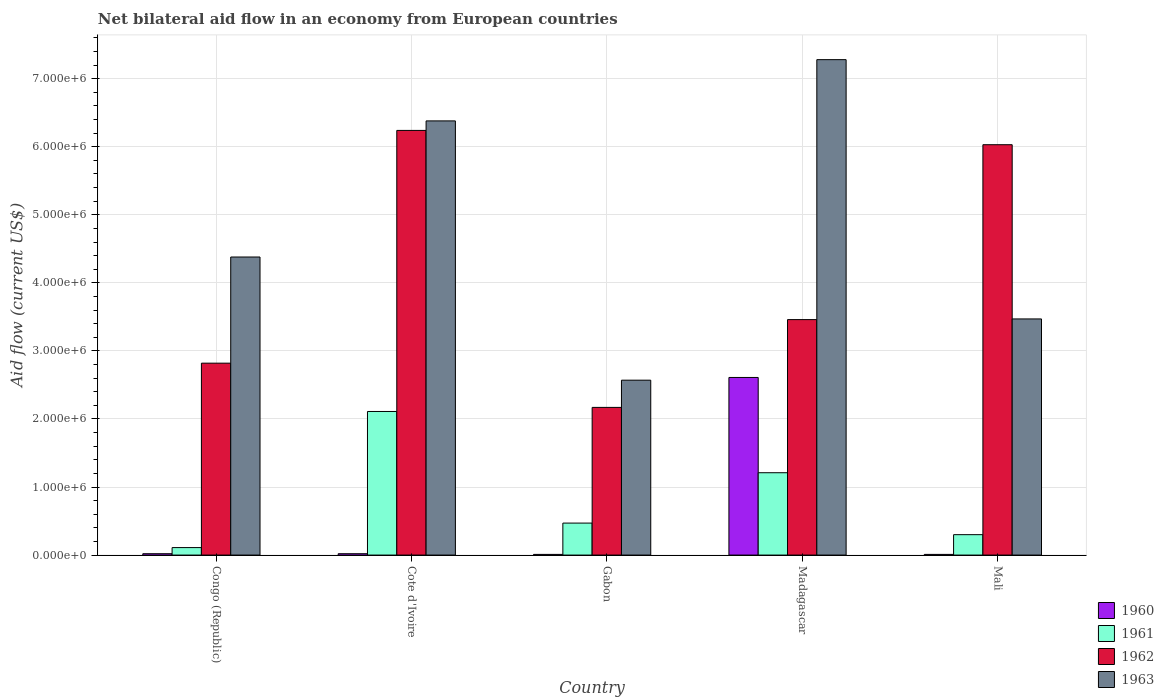How many different coloured bars are there?
Your response must be concise. 4. Are the number of bars per tick equal to the number of legend labels?
Offer a terse response. Yes. How many bars are there on the 4th tick from the right?
Your answer should be compact. 4. What is the label of the 1st group of bars from the left?
Your response must be concise. Congo (Republic). In how many cases, is the number of bars for a given country not equal to the number of legend labels?
Provide a short and direct response. 0. What is the net bilateral aid flow in 1960 in Congo (Republic)?
Offer a very short reply. 2.00e+04. Across all countries, what is the maximum net bilateral aid flow in 1960?
Your response must be concise. 2.61e+06. Across all countries, what is the minimum net bilateral aid flow in 1963?
Make the answer very short. 2.57e+06. In which country was the net bilateral aid flow in 1960 maximum?
Offer a terse response. Madagascar. In which country was the net bilateral aid flow in 1962 minimum?
Give a very brief answer. Gabon. What is the total net bilateral aid flow in 1962 in the graph?
Provide a short and direct response. 2.07e+07. What is the difference between the net bilateral aid flow in 1963 in Cote d'Ivoire and that in Madagascar?
Your response must be concise. -9.00e+05. What is the difference between the net bilateral aid flow in 1960 in Gabon and the net bilateral aid flow in 1962 in Mali?
Your response must be concise. -6.02e+06. What is the average net bilateral aid flow in 1962 per country?
Offer a very short reply. 4.14e+06. What is the difference between the net bilateral aid flow of/in 1960 and net bilateral aid flow of/in 1963 in Cote d'Ivoire?
Provide a succinct answer. -6.36e+06. What is the ratio of the net bilateral aid flow in 1960 in Congo (Republic) to that in Madagascar?
Your answer should be compact. 0.01. Is the net bilateral aid flow in 1963 in Congo (Republic) less than that in Madagascar?
Keep it short and to the point. Yes. What is the difference between the highest and the second highest net bilateral aid flow in 1960?
Offer a very short reply. 2.59e+06. What is the difference between the highest and the lowest net bilateral aid flow in 1960?
Give a very brief answer. 2.60e+06. Is the sum of the net bilateral aid flow in 1960 in Cote d'Ivoire and Madagascar greater than the maximum net bilateral aid flow in 1963 across all countries?
Keep it short and to the point. No. Is it the case that in every country, the sum of the net bilateral aid flow in 1961 and net bilateral aid flow in 1963 is greater than the sum of net bilateral aid flow in 1960 and net bilateral aid flow in 1962?
Offer a very short reply. No. How many bars are there?
Offer a very short reply. 20. What is the difference between two consecutive major ticks on the Y-axis?
Keep it short and to the point. 1.00e+06. Are the values on the major ticks of Y-axis written in scientific E-notation?
Offer a very short reply. Yes. Does the graph contain any zero values?
Your answer should be compact. No. Where does the legend appear in the graph?
Offer a terse response. Bottom right. How are the legend labels stacked?
Provide a short and direct response. Vertical. What is the title of the graph?
Your response must be concise. Net bilateral aid flow in an economy from European countries. What is the label or title of the X-axis?
Provide a short and direct response. Country. What is the Aid flow (current US$) in 1960 in Congo (Republic)?
Your answer should be compact. 2.00e+04. What is the Aid flow (current US$) of 1961 in Congo (Republic)?
Your response must be concise. 1.10e+05. What is the Aid flow (current US$) of 1962 in Congo (Republic)?
Your answer should be very brief. 2.82e+06. What is the Aid flow (current US$) of 1963 in Congo (Republic)?
Provide a succinct answer. 4.38e+06. What is the Aid flow (current US$) of 1960 in Cote d'Ivoire?
Give a very brief answer. 2.00e+04. What is the Aid flow (current US$) of 1961 in Cote d'Ivoire?
Offer a very short reply. 2.11e+06. What is the Aid flow (current US$) of 1962 in Cote d'Ivoire?
Your answer should be very brief. 6.24e+06. What is the Aid flow (current US$) in 1963 in Cote d'Ivoire?
Provide a short and direct response. 6.38e+06. What is the Aid flow (current US$) in 1960 in Gabon?
Your answer should be compact. 10000. What is the Aid flow (current US$) in 1962 in Gabon?
Provide a short and direct response. 2.17e+06. What is the Aid flow (current US$) in 1963 in Gabon?
Your answer should be compact. 2.57e+06. What is the Aid flow (current US$) of 1960 in Madagascar?
Offer a very short reply. 2.61e+06. What is the Aid flow (current US$) in 1961 in Madagascar?
Ensure brevity in your answer.  1.21e+06. What is the Aid flow (current US$) in 1962 in Madagascar?
Give a very brief answer. 3.46e+06. What is the Aid flow (current US$) in 1963 in Madagascar?
Your answer should be very brief. 7.28e+06. What is the Aid flow (current US$) in 1962 in Mali?
Give a very brief answer. 6.03e+06. What is the Aid flow (current US$) in 1963 in Mali?
Your answer should be compact. 3.47e+06. Across all countries, what is the maximum Aid flow (current US$) of 1960?
Provide a succinct answer. 2.61e+06. Across all countries, what is the maximum Aid flow (current US$) of 1961?
Your answer should be very brief. 2.11e+06. Across all countries, what is the maximum Aid flow (current US$) in 1962?
Ensure brevity in your answer.  6.24e+06. Across all countries, what is the maximum Aid flow (current US$) of 1963?
Give a very brief answer. 7.28e+06. Across all countries, what is the minimum Aid flow (current US$) in 1962?
Offer a terse response. 2.17e+06. Across all countries, what is the minimum Aid flow (current US$) of 1963?
Provide a succinct answer. 2.57e+06. What is the total Aid flow (current US$) in 1960 in the graph?
Keep it short and to the point. 2.67e+06. What is the total Aid flow (current US$) of 1961 in the graph?
Make the answer very short. 4.20e+06. What is the total Aid flow (current US$) of 1962 in the graph?
Offer a terse response. 2.07e+07. What is the total Aid flow (current US$) in 1963 in the graph?
Your answer should be compact. 2.41e+07. What is the difference between the Aid flow (current US$) in 1962 in Congo (Republic) and that in Cote d'Ivoire?
Your answer should be very brief. -3.42e+06. What is the difference between the Aid flow (current US$) in 1963 in Congo (Republic) and that in Cote d'Ivoire?
Offer a very short reply. -2.00e+06. What is the difference between the Aid flow (current US$) in 1961 in Congo (Republic) and that in Gabon?
Keep it short and to the point. -3.60e+05. What is the difference between the Aid flow (current US$) of 1962 in Congo (Republic) and that in Gabon?
Ensure brevity in your answer.  6.50e+05. What is the difference between the Aid flow (current US$) of 1963 in Congo (Republic) and that in Gabon?
Offer a terse response. 1.81e+06. What is the difference between the Aid flow (current US$) in 1960 in Congo (Republic) and that in Madagascar?
Give a very brief answer. -2.59e+06. What is the difference between the Aid flow (current US$) of 1961 in Congo (Republic) and that in Madagascar?
Your answer should be compact. -1.10e+06. What is the difference between the Aid flow (current US$) of 1962 in Congo (Republic) and that in Madagascar?
Ensure brevity in your answer.  -6.40e+05. What is the difference between the Aid flow (current US$) of 1963 in Congo (Republic) and that in Madagascar?
Keep it short and to the point. -2.90e+06. What is the difference between the Aid flow (current US$) in 1961 in Congo (Republic) and that in Mali?
Keep it short and to the point. -1.90e+05. What is the difference between the Aid flow (current US$) in 1962 in Congo (Republic) and that in Mali?
Your answer should be compact. -3.21e+06. What is the difference between the Aid flow (current US$) of 1963 in Congo (Republic) and that in Mali?
Keep it short and to the point. 9.10e+05. What is the difference between the Aid flow (current US$) of 1961 in Cote d'Ivoire and that in Gabon?
Ensure brevity in your answer.  1.64e+06. What is the difference between the Aid flow (current US$) of 1962 in Cote d'Ivoire and that in Gabon?
Your answer should be compact. 4.07e+06. What is the difference between the Aid flow (current US$) of 1963 in Cote d'Ivoire and that in Gabon?
Provide a short and direct response. 3.81e+06. What is the difference between the Aid flow (current US$) in 1960 in Cote d'Ivoire and that in Madagascar?
Your response must be concise. -2.59e+06. What is the difference between the Aid flow (current US$) in 1961 in Cote d'Ivoire and that in Madagascar?
Provide a succinct answer. 9.00e+05. What is the difference between the Aid flow (current US$) in 1962 in Cote d'Ivoire and that in Madagascar?
Ensure brevity in your answer.  2.78e+06. What is the difference between the Aid flow (current US$) in 1963 in Cote d'Ivoire and that in Madagascar?
Your answer should be compact. -9.00e+05. What is the difference between the Aid flow (current US$) in 1960 in Cote d'Ivoire and that in Mali?
Make the answer very short. 10000. What is the difference between the Aid flow (current US$) in 1961 in Cote d'Ivoire and that in Mali?
Offer a very short reply. 1.81e+06. What is the difference between the Aid flow (current US$) of 1963 in Cote d'Ivoire and that in Mali?
Keep it short and to the point. 2.91e+06. What is the difference between the Aid flow (current US$) in 1960 in Gabon and that in Madagascar?
Keep it short and to the point. -2.60e+06. What is the difference between the Aid flow (current US$) of 1961 in Gabon and that in Madagascar?
Your answer should be compact. -7.40e+05. What is the difference between the Aid flow (current US$) of 1962 in Gabon and that in Madagascar?
Offer a very short reply. -1.29e+06. What is the difference between the Aid flow (current US$) of 1963 in Gabon and that in Madagascar?
Provide a succinct answer. -4.71e+06. What is the difference between the Aid flow (current US$) of 1960 in Gabon and that in Mali?
Keep it short and to the point. 0. What is the difference between the Aid flow (current US$) of 1961 in Gabon and that in Mali?
Ensure brevity in your answer.  1.70e+05. What is the difference between the Aid flow (current US$) in 1962 in Gabon and that in Mali?
Your answer should be very brief. -3.86e+06. What is the difference between the Aid flow (current US$) in 1963 in Gabon and that in Mali?
Keep it short and to the point. -9.00e+05. What is the difference between the Aid flow (current US$) in 1960 in Madagascar and that in Mali?
Provide a short and direct response. 2.60e+06. What is the difference between the Aid flow (current US$) in 1961 in Madagascar and that in Mali?
Keep it short and to the point. 9.10e+05. What is the difference between the Aid flow (current US$) in 1962 in Madagascar and that in Mali?
Your response must be concise. -2.57e+06. What is the difference between the Aid flow (current US$) of 1963 in Madagascar and that in Mali?
Provide a short and direct response. 3.81e+06. What is the difference between the Aid flow (current US$) of 1960 in Congo (Republic) and the Aid flow (current US$) of 1961 in Cote d'Ivoire?
Offer a very short reply. -2.09e+06. What is the difference between the Aid flow (current US$) in 1960 in Congo (Republic) and the Aid flow (current US$) in 1962 in Cote d'Ivoire?
Keep it short and to the point. -6.22e+06. What is the difference between the Aid flow (current US$) of 1960 in Congo (Republic) and the Aid flow (current US$) of 1963 in Cote d'Ivoire?
Provide a succinct answer. -6.36e+06. What is the difference between the Aid flow (current US$) of 1961 in Congo (Republic) and the Aid flow (current US$) of 1962 in Cote d'Ivoire?
Provide a succinct answer. -6.13e+06. What is the difference between the Aid flow (current US$) in 1961 in Congo (Republic) and the Aid flow (current US$) in 1963 in Cote d'Ivoire?
Make the answer very short. -6.27e+06. What is the difference between the Aid flow (current US$) in 1962 in Congo (Republic) and the Aid flow (current US$) in 1963 in Cote d'Ivoire?
Keep it short and to the point. -3.56e+06. What is the difference between the Aid flow (current US$) of 1960 in Congo (Republic) and the Aid flow (current US$) of 1961 in Gabon?
Offer a very short reply. -4.50e+05. What is the difference between the Aid flow (current US$) of 1960 in Congo (Republic) and the Aid flow (current US$) of 1962 in Gabon?
Make the answer very short. -2.15e+06. What is the difference between the Aid flow (current US$) of 1960 in Congo (Republic) and the Aid flow (current US$) of 1963 in Gabon?
Ensure brevity in your answer.  -2.55e+06. What is the difference between the Aid flow (current US$) in 1961 in Congo (Republic) and the Aid flow (current US$) in 1962 in Gabon?
Provide a succinct answer. -2.06e+06. What is the difference between the Aid flow (current US$) of 1961 in Congo (Republic) and the Aid flow (current US$) of 1963 in Gabon?
Offer a terse response. -2.46e+06. What is the difference between the Aid flow (current US$) in 1962 in Congo (Republic) and the Aid flow (current US$) in 1963 in Gabon?
Offer a very short reply. 2.50e+05. What is the difference between the Aid flow (current US$) of 1960 in Congo (Republic) and the Aid flow (current US$) of 1961 in Madagascar?
Your answer should be very brief. -1.19e+06. What is the difference between the Aid flow (current US$) of 1960 in Congo (Republic) and the Aid flow (current US$) of 1962 in Madagascar?
Your answer should be very brief. -3.44e+06. What is the difference between the Aid flow (current US$) in 1960 in Congo (Republic) and the Aid flow (current US$) in 1963 in Madagascar?
Your response must be concise. -7.26e+06. What is the difference between the Aid flow (current US$) in 1961 in Congo (Republic) and the Aid flow (current US$) in 1962 in Madagascar?
Your response must be concise. -3.35e+06. What is the difference between the Aid flow (current US$) of 1961 in Congo (Republic) and the Aid flow (current US$) of 1963 in Madagascar?
Give a very brief answer. -7.17e+06. What is the difference between the Aid flow (current US$) in 1962 in Congo (Republic) and the Aid flow (current US$) in 1963 in Madagascar?
Give a very brief answer. -4.46e+06. What is the difference between the Aid flow (current US$) of 1960 in Congo (Republic) and the Aid flow (current US$) of 1961 in Mali?
Your answer should be compact. -2.80e+05. What is the difference between the Aid flow (current US$) in 1960 in Congo (Republic) and the Aid flow (current US$) in 1962 in Mali?
Provide a succinct answer. -6.01e+06. What is the difference between the Aid flow (current US$) of 1960 in Congo (Republic) and the Aid flow (current US$) of 1963 in Mali?
Your answer should be compact. -3.45e+06. What is the difference between the Aid flow (current US$) of 1961 in Congo (Republic) and the Aid flow (current US$) of 1962 in Mali?
Make the answer very short. -5.92e+06. What is the difference between the Aid flow (current US$) in 1961 in Congo (Republic) and the Aid flow (current US$) in 1963 in Mali?
Offer a very short reply. -3.36e+06. What is the difference between the Aid flow (current US$) of 1962 in Congo (Republic) and the Aid flow (current US$) of 1963 in Mali?
Offer a terse response. -6.50e+05. What is the difference between the Aid flow (current US$) of 1960 in Cote d'Ivoire and the Aid flow (current US$) of 1961 in Gabon?
Keep it short and to the point. -4.50e+05. What is the difference between the Aid flow (current US$) in 1960 in Cote d'Ivoire and the Aid flow (current US$) in 1962 in Gabon?
Make the answer very short. -2.15e+06. What is the difference between the Aid flow (current US$) in 1960 in Cote d'Ivoire and the Aid flow (current US$) in 1963 in Gabon?
Your response must be concise. -2.55e+06. What is the difference between the Aid flow (current US$) in 1961 in Cote d'Ivoire and the Aid flow (current US$) in 1962 in Gabon?
Offer a terse response. -6.00e+04. What is the difference between the Aid flow (current US$) of 1961 in Cote d'Ivoire and the Aid flow (current US$) of 1963 in Gabon?
Provide a short and direct response. -4.60e+05. What is the difference between the Aid flow (current US$) in 1962 in Cote d'Ivoire and the Aid flow (current US$) in 1963 in Gabon?
Your answer should be compact. 3.67e+06. What is the difference between the Aid flow (current US$) in 1960 in Cote d'Ivoire and the Aid flow (current US$) in 1961 in Madagascar?
Offer a very short reply. -1.19e+06. What is the difference between the Aid flow (current US$) of 1960 in Cote d'Ivoire and the Aid flow (current US$) of 1962 in Madagascar?
Offer a very short reply. -3.44e+06. What is the difference between the Aid flow (current US$) in 1960 in Cote d'Ivoire and the Aid flow (current US$) in 1963 in Madagascar?
Keep it short and to the point. -7.26e+06. What is the difference between the Aid flow (current US$) of 1961 in Cote d'Ivoire and the Aid flow (current US$) of 1962 in Madagascar?
Keep it short and to the point. -1.35e+06. What is the difference between the Aid flow (current US$) in 1961 in Cote d'Ivoire and the Aid flow (current US$) in 1963 in Madagascar?
Offer a terse response. -5.17e+06. What is the difference between the Aid flow (current US$) in 1962 in Cote d'Ivoire and the Aid flow (current US$) in 1963 in Madagascar?
Give a very brief answer. -1.04e+06. What is the difference between the Aid flow (current US$) in 1960 in Cote d'Ivoire and the Aid flow (current US$) in 1961 in Mali?
Ensure brevity in your answer.  -2.80e+05. What is the difference between the Aid flow (current US$) of 1960 in Cote d'Ivoire and the Aid flow (current US$) of 1962 in Mali?
Provide a succinct answer. -6.01e+06. What is the difference between the Aid flow (current US$) in 1960 in Cote d'Ivoire and the Aid flow (current US$) in 1963 in Mali?
Provide a short and direct response. -3.45e+06. What is the difference between the Aid flow (current US$) in 1961 in Cote d'Ivoire and the Aid flow (current US$) in 1962 in Mali?
Your answer should be very brief. -3.92e+06. What is the difference between the Aid flow (current US$) in 1961 in Cote d'Ivoire and the Aid flow (current US$) in 1963 in Mali?
Offer a terse response. -1.36e+06. What is the difference between the Aid flow (current US$) in 1962 in Cote d'Ivoire and the Aid flow (current US$) in 1963 in Mali?
Keep it short and to the point. 2.77e+06. What is the difference between the Aid flow (current US$) in 1960 in Gabon and the Aid flow (current US$) in 1961 in Madagascar?
Keep it short and to the point. -1.20e+06. What is the difference between the Aid flow (current US$) in 1960 in Gabon and the Aid flow (current US$) in 1962 in Madagascar?
Make the answer very short. -3.45e+06. What is the difference between the Aid flow (current US$) in 1960 in Gabon and the Aid flow (current US$) in 1963 in Madagascar?
Your answer should be compact. -7.27e+06. What is the difference between the Aid flow (current US$) of 1961 in Gabon and the Aid flow (current US$) of 1962 in Madagascar?
Make the answer very short. -2.99e+06. What is the difference between the Aid flow (current US$) of 1961 in Gabon and the Aid flow (current US$) of 1963 in Madagascar?
Offer a terse response. -6.81e+06. What is the difference between the Aid flow (current US$) of 1962 in Gabon and the Aid flow (current US$) of 1963 in Madagascar?
Your answer should be very brief. -5.11e+06. What is the difference between the Aid flow (current US$) of 1960 in Gabon and the Aid flow (current US$) of 1961 in Mali?
Offer a very short reply. -2.90e+05. What is the difference between the Aid flow (current US$) in 1960 in Gabon and the Aid flow (current US$) in 1962 in Mali?
Your answer should be compact. -6.02e+06. What is the difference between the Aid flow (current US$) of 1960 in Gabon and the Aid flow (current US$) of 1963 in Mali?
Give a very brief answer. -3.46e+06. What is the difference between the Aid flow (current US$) of 1961 in Gabon and the Aid flow (current US$) of 1962 in Mali?
Offer a terse response. -5.56e+06. What is the difference between the Aid flow (current US$) of 1961 in Gabon and the Aid flow (current US$) of 1963 in Mali?
Your response must be concise. -3.00e+06. What is the difference between the Aid flow (current US$) of 1962 in Gabon and the Aid flow (current US$) of 1963 in Mali?
Your answer should be very brief. -1.30e+06. What is the difference between the Aid flow (current US$) of 1960 in Madagascar and the Aid flow (current US$) of 1961 in Mali?
Ensure brevity in your answer.  2.31e+06. What is the difference between the Aid flow (current US$) of 1960 in Madagascar and the Aid flow (current US$) of 1962 in Mali?
Keep it short and to the point. -3.42e+06. What is the difference between the Aid flow (current US$) of 1960 in Madagascar and the Aid flow (current US$) of 1963 in Mali?
Provide a short and direct response. -8.60e+05. What is the difference between the Aid flow (current US$) of 1961 in Madagascar and the Aid flow (current US$) of 1962 in Mali?
Give a very brief answer. -4.82e+06. What is the difference between the Aid flow (current US$) in 1961 in Madagascar and the Aid flow (current US$) in 1963 in Mali?
Provide a short and direct response. -2.26e+06. What is the difference between the Aid flow (current US$) of 1962 in Madagascar and the Aid flow (current US$) of 1963 in Mali?
Keep it short and to the point. -10000. What is the average Aid flow (current US$) of 1960 per country?
Offer a terse response. 5.34e+05. What is the average Aid flow (current US$) of 1961 per country?
Keep it short and to the point. 8.40e+05. What is the average Aid flow (current US$) of 1962 per country?
Your answer should be compact. 4.14e+06. What is the average Aid flow (current US$) in 1963 per country?
Your answer should be very brief. 4.82e+06. What is the difference between the Aid flow (current US$) of 1960 and Aid flow (current US$) of 1962 in Congo (Republic)?
Your response must be concise. -2.80e+06. What is the difference between the Aid flow (current US$) of 1960 and Aid flow (current US$) of 1963 in Congo (Republic)?
Give a very brief answer. -4.36e+06. What is the difference between the Aid flow (current US$) in 1961 and Aid flow (current US$) in 1962 in Congo (Republic)?
Your response must be concise. -2.71e+06. What is the difference between the Aid flow (current US$) in 1961 and Aid flow (current US$) in 1963 in Congo (Republic)?
Your response must be concise. -4.27e+06. What is the difference between the Aid flow (current US$) of 1962 and Aid flow (current US$) of 1963 in Congo (Republic)?
Provide a short and direct response. -1.56e+06. What is the difference between the Aid flow (current US$) of 1960 and Aid flow (current US$) of 1961 in Cote d'Ivoire?
Offer a terse response. -2.09e+06. What is the difference between the Aid flow (current US$) in 1960 and Aid flow (current US$) in 1962 in Cote d'Ivoire?
Provide a succinct answer. -6.22e+06. What is the difference between the Aid flow (current US$) in 1960 and Aid flow (current US$) in 1963 in Cote d'Ivoire?
Offer a terse response. -6.36e+06. What is the difference between the Aid flow (current US$) of 1961 and Aid flow (current US$) of 1962 in Cote d'Ivoire?
Ensure brevity in your answer.  -4.13e+06. What is the difference between the Aid flow (current US$) of 1961 and Aid flow (current US$) of 1963 in Cote d'Ivoire?
Keep it short and to the point. -4.27e+06. What is the difference between the Aid flow (current US$) of 1960 and Aid flow (current US$) of 1961 in Gabon?
Offer a very short reply. -4.60e+05. What is the difference between the Aid flow (current US$) of 1960 and Aid flow (current US$) of 1962 in Gabon?
Make the answer very short. -2.16e+06. What is the difference between the Aid flow (current US$) of 1960 and Aid flow (current US$) of 1963 in Gabon?
Make the answer very short. -2.56e+06. What is the difference between the Aid flow (current US$) in 1961 and Aid flow (current US$) in 1962 in Gabon?
Offer a terse response. -1.70e+06. What is the difference between the Aid flow (current US$) in 1961 and Aid flow (current US$) in 1963 in Gabon?
Give a very brief answer. -2.10e+06. What is the difference between the Aid flow (current US$) of 1962 and Aid flow (current US$) of 1963 in Gabon?
Give a very brief answer. -4.00e+05. What is the difference between the Aid flow (current US$) of 1960 and Aid flow (current US$) of 1961 in Madagascar?
Offer a very short reply. 1.40e+06. What is the difference between the Aid flow (current US$) in 1960 and Aid flow (current US$) in 1962 in Madagascar?
Your answer should be very brief. -8.50e+05. What is the difference between the Aid flow (current US$) in 1960 and Aid flow (current US$) in 1963 in Madagascar?
Offer a very short reply. -4.67e+06. What is the difference between the Aid flow (current US$) in 1961 and Aid flow (current US$) in 1962 in Madagascar?
Offer a very short reply. -2.25e+06. What is the difference between the Aid flow (current US$) of 1961 and Aid flow (current US$) of 1963 in Madagascar?
Ensure brevity in your answer.  -6.07e+06. What is the difference between the Aid flow (current US$) of 1962 and Aid flow (current US$) of 1963 in Madagascar?
Keep it short and to the point. -3.82e+06. What is the difference between the Aid flow (current US$) in 1960 and Aid flow (current US$) in 1962 in Mali?
Give a very brief answer. -6.02e+06. What is the difference between the Aid flow (current US$) in 1960 and Aid flow (current US$) in 1963 in Mali?
Offer a very short reply. -3.46e+06. What is the difference between the Aid flow (current US$) in 1961 and Aid flow (current US$) in 1962 in Mali?
Your answer should be compact. -5.73e+06. What is the difference between the Aid flow (current US$) in 1961 and Aid flow (current US$) in 1963 in Mali?
Offer a very short reply. -3.17e+06. What is the difference between the Aid flow (current US$) in 1962 and Aid flow (current US$) in 1963 in Mali?
Your answer should be compact. 2.56e+06. What is the ratio of the Aid flow (current US$) of 1960 in Congo (Republic) to that in Cote d'Ivoire?
Make the answer very short. 1. What is the ratio of the Aid flow (current US$) in 1961 in Congo (Republic) to that in Cote d'Ivoire?
Offer a very short reply. 0.05. What is the ratio of the Aid flow (current US$) of 1962 in Congo (Republic) to that in Cote d'Ivoire?
Keep it short and to the point. 0.45. What is the ratio of the Aid flow (current US$) of 1963 in Congo (Republic) to that in Cote d'Ivoire?
Your answer should be compact. 0.69. What is the ratio of the Aid flow (current US$) of 1960 in Congo (Republic) to that in Gabon?
Your answer should be very brief. 2. What is the ratio of the Aid flow (current US$) in 1961 in Congo (Republic) to that in Gabon?
Ensure brevity in your answer.  0.23. What is the ratio of the Aid flow (current US$) in 1962 in Congo (Republic) to that in Gabon?
Your answer should be compact. 1.3. What is the ratio of the Aid flow (current US$) of 1963 in Congo (Republic) to that in Gabon?
Your answer should be very brief. 1.7. What is the ratio of the Aid flow (current US$) of 1960 in Congo (Republic) to that in Madagascar?
Keep it short and to the point. 0.01. What is the ratio of the Aid flow (current US$) of 1961 in Congo (Republic) to that in Madagascar?
Provide a succinct answer. 0.09. What is the ratio of the Aid flow (current US$) of 1962 in Congo (Republic) to that in Madagascar?
Your response must be concise. 0.81. What is the ratio of the Aid flow (current US$) in 1963 in Congo (Republic) to that in Madagascar?
Your response must be concise. 0.6. What is the ratio of the Aid flow (current US$) in 1961 in Congo (Republic) to that in Mali?
Provide a short and direct response. 0.37. What is the ratio of the Aid flow (current US$) in 1962 in Congo (Republic) to that in Mali?
Provide a short and direct response. 0.47. What is the ratio of the Aid flow (current US$) in 1963 in Congo (Republic) to that in Mali?
Keep it short and to the point. 1.26. What is the ratio of the Aid flow (current US$) in 1961 in Cote d'Ivoire to that in Gabon?
Offer a terse response. 4.49. What is the ratio of the Aid flow (current US$) of 1962 in Cote d'Ivoire to that in Gabon?
Provide a short and direct response. 2.88. What is the ratio of the Aid flow (current US$) in 1963 in Cote d'Ivoire to that in Gabon?
Provide a short and direct response. 2.48. What is the ratio of the Aid flow (current US$) in 1960 in Cote d'Ivoire to that in Madagascar?
Offer a terse response. 0.01. What is the ratio of the Aid flow (current US$) in 1961 in Cote d'Ivoire to that in Madagascar?
Ensure brevity in your answer.  1.74. What is the ratio of the Aid flow (current US$) of 1962 in Cote d'Ivoire to that in Madagascar?
Keep it short and to the point. 1.8. What is the ratio of the Aid flow (current US$) of 1963 in Cote d'Ivoire to that in Madagascar?
Provide a short and direct response. 0.88. What is the ratio of the Aid flow (current US$) in 1960 in Cote d'Ivoire to that in Mali?
Offer a very short reply. 2. What is the ratio of the Aid flow (current US$) of 1961 in Cote d'Ivoire to that in Mali?
Your response must be concise. 7.03. What is the ratio of the Aid flow (current US$) in 1962 in Cote d'Ivoire to that in Mali?
Give a very brief answer. 1.03. What is the ratio of the Aid flow (current US$) of 1963 in Cote d'Ivoire to that in Mali?
Ensure brevity in your answer.  1.84. What is the ratio of the Aid flow (current US$) in 1960 in Gabon to that in Madagascar?
Offer a very short reply. 0. What is the ratio of the Aid flow (current US$) in 1961 in Gabon to that in Madagascar?
Offer a very short reply. 0.39. What is the ratio of the Aid flow (current US$) of 1962 in Gabon to that in Madagascar?
Give a very brief answer. 0.63. What is the ratio of the Aid flow (current US$) in 1963 in Gabon to that in Madagascar?
Your answer should be very brief. 0.35. What is the ratio of the Aid flow (current US$) of 1960 in Gabon to that in Mali?
Offer a very short reply. 1. What is the ratio of the Aid flow (current US$) in 1961 in Gabon to that in Mali?
Your answer should be compact. 1.57. What is the ratio of the Aid flow (current US$) in 1962 in Gabon to that in Mali?
Offer a terse response. 0.36. What is the ratio of the Aid flow (current US$) of 1963 in Gabon to that in Mali?
Your answer should be very brief. 0.74. What is the ratio of the Aid flow (current US$) of 1960 in Madagascar to that in Mali?
Give a very brief answer. 261. What is the ratio of the Aid flow (current US$) in 1961 in Madagascar to that in Mali?
Offer a very short reply. 4.03. What is the ratio of the Aid flow (current US$) in 1962 in Madagascar to that in Mali?
Provide a succinct answer. 0.57. What is the ratio of the Aid flow (current US$) of 1963 in Madagascar to that in Mali?
Make the answer very short. 2.1. What is the difference between the highest and the second highest Aid flow (current US$) of 1960?
Keep it short and to the point. 2.59e+06. What is the difference between the highest and the second highest Aid flow (current US$) of 1961?
Provide a succinct answer. 9.00e+05. What is the difference between the highest and the second highest Aid flow (current US$) of 1963?
Give a very brief answer. 9.00e+05. What is the difference between the highest and the lowest Aid flow (current US$) in 1960?
Offer a terse response. 2.60e+06. What is the difference between the highest and the lowest Aid flow (current US$) of 1961?
Make the answer very short. 2.00e+06. What is the difference between the highest and the lowest Aid flow (current US$) of 1962?
Provide a succinct answer. 4.07e+06. What is the difference between the highest and the lowest Aid flow (current US$) in 1963?
Your answer should be very brief. 4.71e+06. 